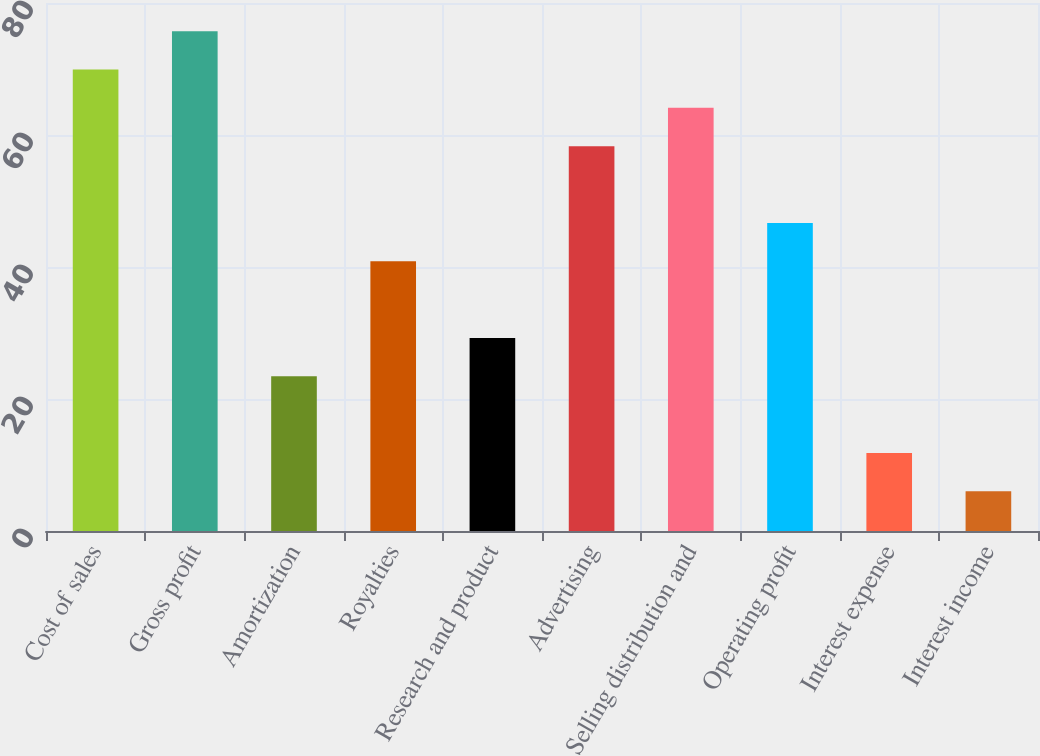Convert chart to OTSL. <chart><loc_0><loc_0><loc_500><loc_500><bar_chart><fcel>Cost of sales<fcel>Gross profit<fcel>Amortization<fcel>Royalties<fcel>Research and product<fcel>Advertising<fcel>Selling distribution and<fcel>Operating profit<fcel>Interest expense<fcel>Interest income<nl><fcel>69.92<fcel>75.73<fcel>23.44<fcel>40.87<fcel>29.25<fcel>58.3<fcel>64.11<fcel>46.68<fcel>11.82<fcel>6.01<nl></chart> 